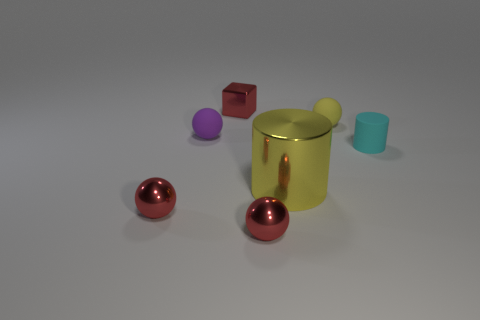Subtract all purple spheres. How many spheres are left? 3 Subtract all small purple balls. How many balls are left? 3 Add 2 small rubber things. How many objects exist? 9 Subtract all blue spheres. Subtract all yellow cylinders. How many spheres are left? 4 Subtract all cylinders. How many objects are left? 5 Add 1 large yellow cylinders. How many large yellow cylinders are left? 2 Add 1 yellow cylinders. How many yellow cylinders exist? 2 Subtract 0 blue cubes. How many objects are left? 7 Subtract all red shiny blocks. Subtract all metallic cylinders. How many objects are left? 5 